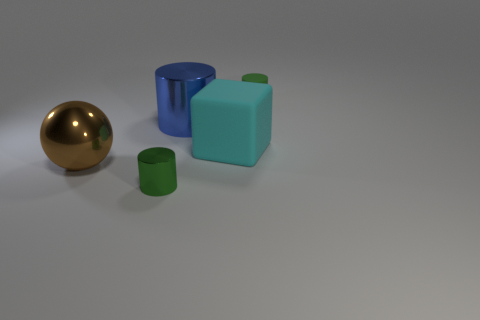Is there any other thing that has the same material as the block?
Offer a very short reply. Yes. There is a rubber cube; is it the same size as the metal cylinder that is behind the large shiny sphere?
Make the answer very short. Yes. What material is the big cube that is behind the green cylinder that is left of the tiny green rubber thing?
Your answer should be very brief. Rubber. Is the number of cyan blocks that are left of the small green metallic cylinder the same as the number of large blue shiny cylinders?
Your answer should be very brief. No. What is the size of the object that is to the right of the big blue object and in front of the green rubber object?
Offer a terse response. Large. There is a thing in front of the large metal thing that is in front of the cyan object; what color is it?
Your answer should be compact. Green. Are there an equal number of rubber objects and small green metal spheres?
Keep it short and to the point. No. What number of gray things are cylinders or tiny cylinders?
Provide a succinct answer. 0. The large object that is both to the left of the large cyan matte cube and right of the large brown sphere is what color?
Provide a succinct answer. Blue. What number of small objects are either cyan rubber blocks or brown metal objects?
Your answer should be compact. 0. 